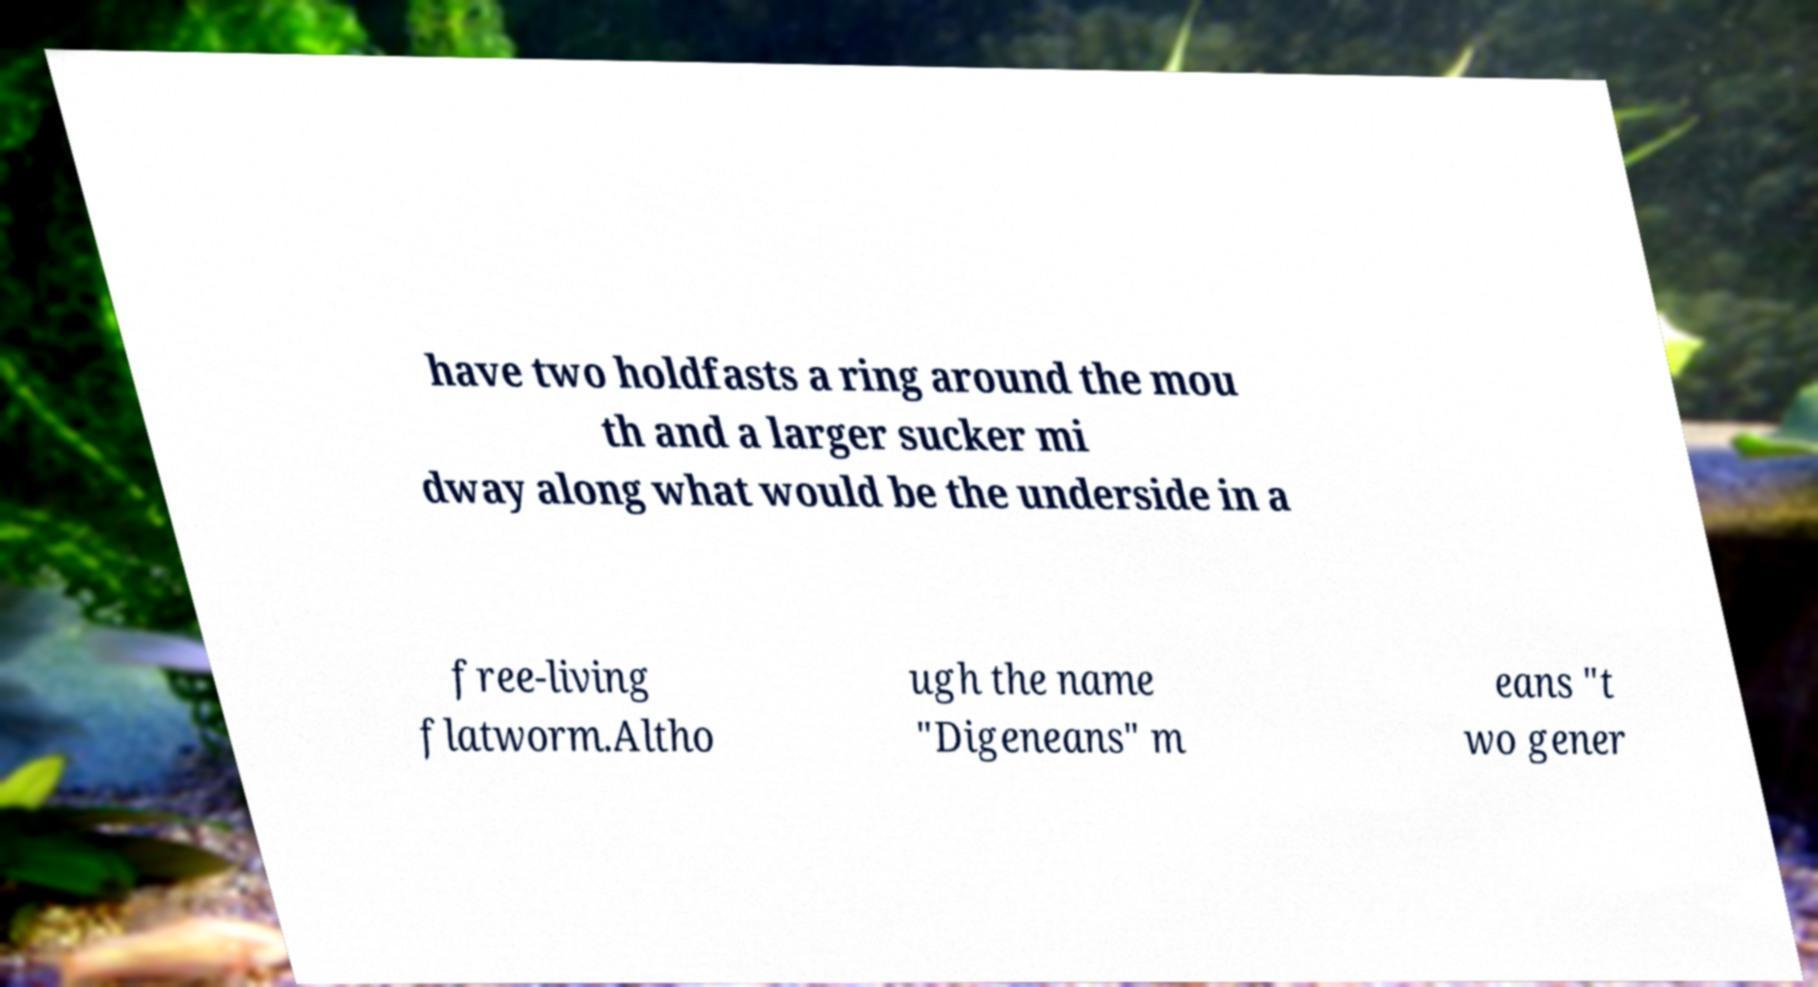Could you assist in decoding the text presented in this image and type it out clearly? have two holdfasts a ring around the mou th and a larger sucker mi dway along what would be the underside in a free-living flatworm.Altho ugh the name "Digeneans" m eans "t wo gener 